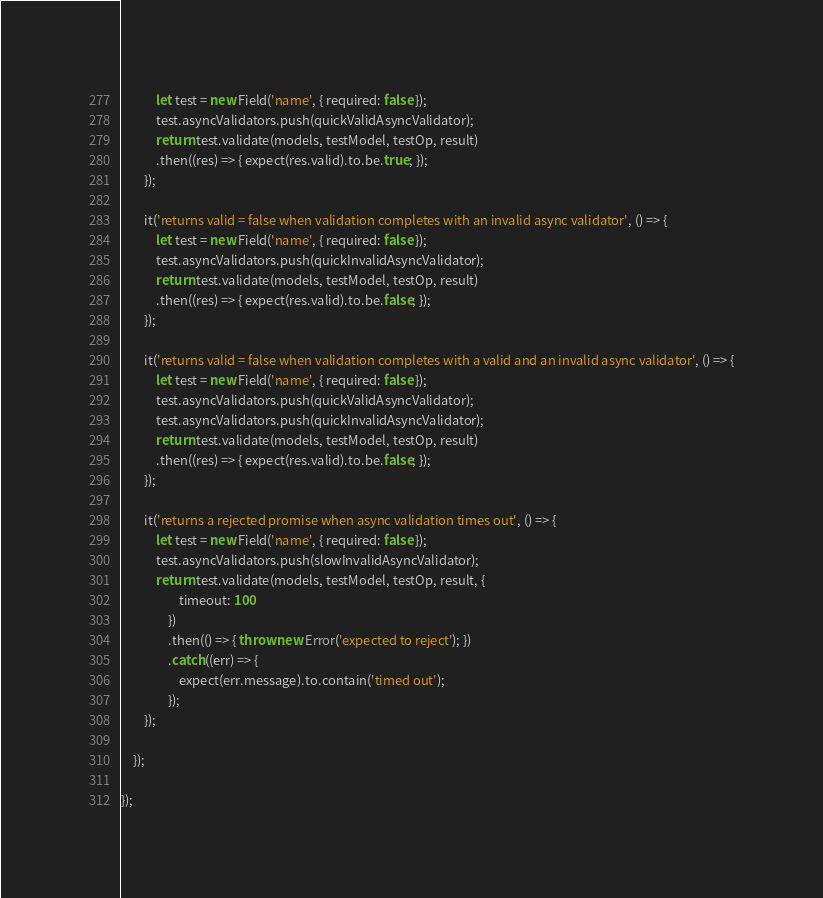<code> <loc_0><loc_0><loc_500><loc_500><_TypeScript_>            let test = new Field('name', { required: false });
            test.asyncValidators.push(quickValidAsyncValidator);
            return test.validate(models, testModel, testOp, result)
            .then((res) => { expect(res.valid).to.be.true; });
        });

        it('returns valid = false when validation completes with an invalid async validator', () => {
            let test = new Field('name', { required: false });
            test.asyncValidators.push(quickInvalidAsyncValidator);
            return test.validate(models, testModel, testOp, result)
            .then((res) => { expect(res.valid).to.be.false; });
        });

        it('returns valid = false when validation completes with a valid and an invalid async validator', () => {
            let test = new Field('name', { required: false });
            test.asyncValidators.push(quickValidAsyncValidator);
            test.asyncValidators.push(quickInvalidAsyncValidator);
            return test.validate(models, testModel, testOp, result)
            .then((res) => { expect(res.valid).to.be.false; });
        });

        it('returns a rejected promise when async validation times out', () => {
            let test = new Field('name', { required: false });
            test.asyncValidators.push(slowInvalidAsyncValidator);
            return test.validate(models, testModel, testOp, result, {
                    timeout: 100
                })
                .then(() => { throw new Error('expected to reject'); })
                .catch((err) => {
                    expect(err.message).to.contain('timed out');
                });
        });

    });

});
</code> 